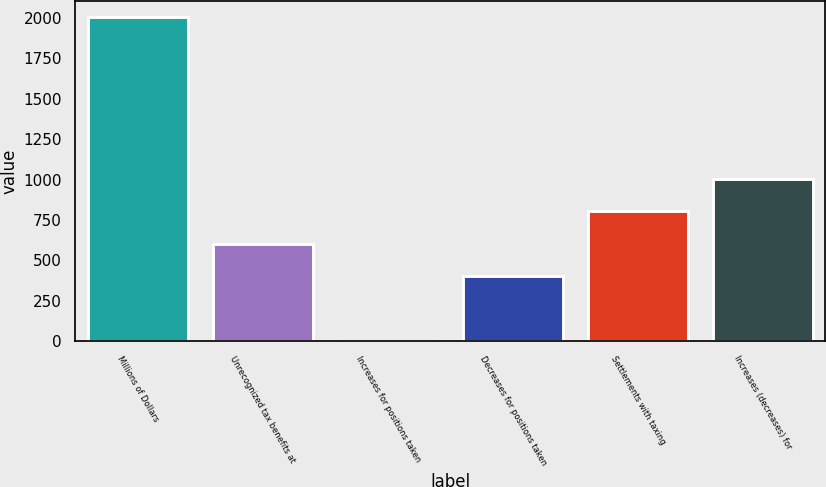<chart> <loc_0><loc_0><loc_500><loc_500><bar_chart><fcel>Millions of Dollars<fcel>Unrecognized tax benefits at<fcel>Increases for positions taken<fcel>Decreases for positions taken<fcel>Settlements with taxing<fcel>Increases (decreases) for<nl><fcel>2008<fcel>603.1<fcel>1<fcel>402.4<fcel>803.8<fcel>1004.5<nl></chart> 